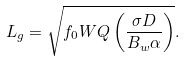Convert formula to latex. <formula><loc_0><loc_0><loc_500><loc_500>L _ { g } = \sqrt { f _ { 0 } W Q \left ( \frac { \sigma D } { B _ { w } \alpha } \right ) } .</formula> 